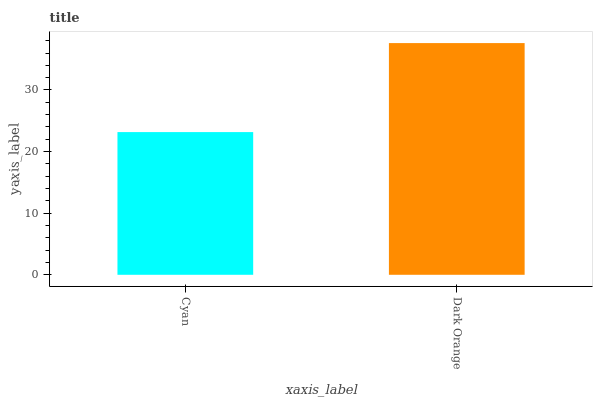Is Cyan the minimum?
Answer yes or no. Yes. Is Dark Orange the maximum?
Answer yes or no. Yes. Is Dark Orange the minimum?
Answer yes or no. No. Is Dark Orange greater than Cyan?
Answer yes or no. Yes. Is Cyan less than Dark Orange?
Answer yes or no. Yes. Is Cyan greater than Dark Orange?
Answer yes or no. No. Is Dark Orange less than Cyan?
Answer yes or no. No. Is Dark Orange the high median?
Answer yes or no. Yes. Is Cyan the low median?
Answer yes or no. Yes. Is Cyan the high median?
Answer yes or no. No. Is Dark Orange the low median?
Answer yes or no. No. 